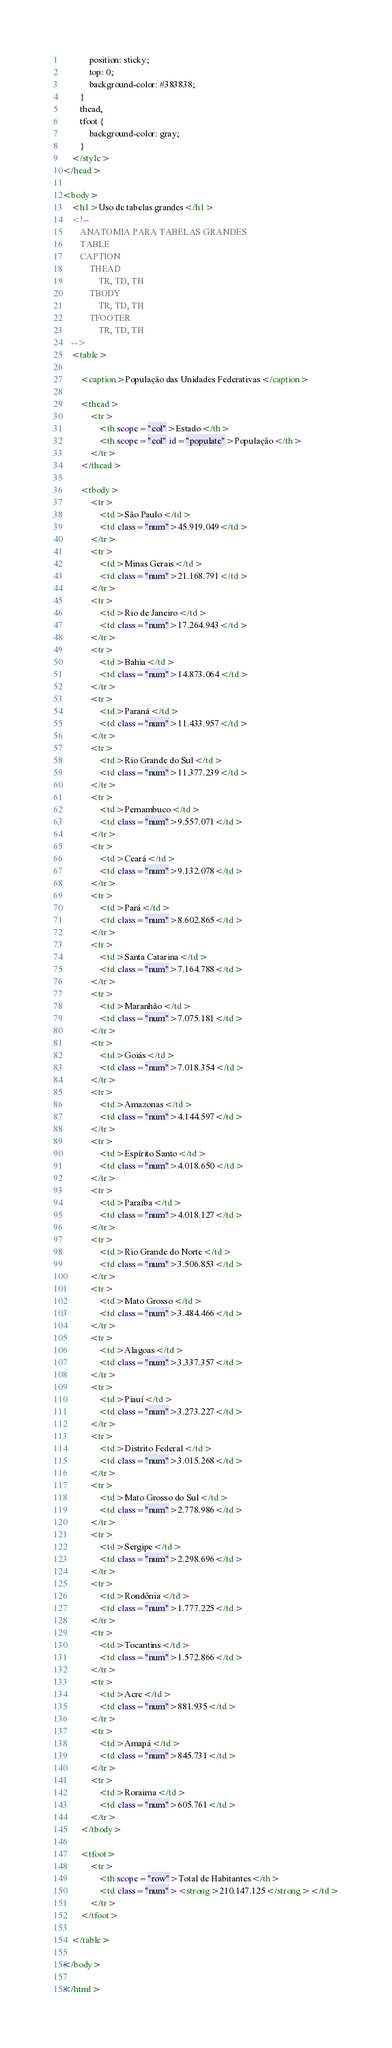Convert code to text. <code><loc_0><loc_0><loc_500><loc_500><_HTML_>            position: sticky;
            top: 0;
            background-color: #383838;
        }
        thead,
        tfoot {
            background-color: gray;
        }
    </style>
</head>

<body>
    <h1>Uso de tabelas grandes</h1>
    <!--
        ANATOMIA PARA TABELAS GRANDES
        TABLE
        CAPTION
            THEAD
                TR, TD, TH
            TBODY
                TR, TD, TH
            TFOOTER
                TR, TD, TH
    -->
    <table>

        <caption>População das Unidades Federativas</caption>

        <thead>
            <tr>
                <th scope="col">Estado</th>
                <th scope="col" id="populate">População</th>
            </tr>
        </thead>

        <tbody>
            <tr>
                <td>São Paulo</td>
                <td class="num">45.919.049</td>
            </tr>
            <tr>
                <td>Minas Gerais</td>
                <td class="num">21.168.791</td>
            </tr>
            <tr>
                <td>Rio de Janeiro</td>
                <td class="num">17.264.943</td>
            </tr>
            <tr>
                <td>Bahia</td>
                <td class="num">14.873.064</td>
            </tr>
            <tr>
                <td>Paraná</td>
                <td class="num">11.433.957</td>
            </tr>
            <tr>
                <td>Rio Grande do Sul</td>
                <td class="num">11.377.239</td>
            </tr>
            <tr>
                <td>Pernambuco</td>
                <td class="num">9.557.071</td>
            </tr>
            <tr>
                <td>Ceará</td>
                <td class="num">9.132.078</td>
            </tr>
            <tr>
                <td>Pará</td>
                <td class="num">8.602.865</td>
            </tr>
            <tr>
                <td>Santa Catarina</td>
                <td class="num">7.164.788</td>
            </tr>
            <tr>
                <td>Maranhão</td>
                <td class="num">7.075.181</td>
            </tr>
            <tr>
                <td>Goiás</td>
                <td class="num">7.018.354</td>
            </tr>
            <tr>
                <td>Amazonas</td>
                <td class="num">4.144.597</td>
            </tr>
            <tr>
                <td>Espírito Santo</td>
                <td class="num">4.018.650</td>
            </tr>
            <tr>
                <td>Paraíba</td>
                <td class="num">4.018.127</td>
            </tr>
            <tr>
                <td>Rio Grande do Norte</td>
                <td class="num">3.506.853</td>
            </tr>
            <tr>
                <td>Mato Grosso</td>
                <td class="num">3.484.466</td>
            </tr>
            <tr>
                <td>Alagoas</td>
                <td class="num">3.337.357</td>
            </tr>
            <tr>
                <td>Piauí</td>
                <td class="num">3.273.227</td>
            </tr>
            <tr>
                <td>Distrito Federal</td>
                <td class="num">3.015.268</td>
            </tr>
            <tr>
                <td>Mato Grosso do Sul</td>
                <td class="num">2.778.986</td>
            </tr>
            <tr>
                <td>Sergipe</td>
                <td class="num">2.298.696</td>
            </tr>
            <tr>
                <td>Rondônia</td>
                <td class="num">1.777.225</td>
            </tr>
            <tr>
                <td>Tocantins</td>
                <td class="num">1.572.866</td>
            </tr>
            <tr>
                <td>Acre</td>
                <td class="num">881.935</td>
            </tr>
            <tr>
                <td>Amapá</td>
                <td class="num">845.731</td>
            </tr>
            <tr>
                <td>Roraima</td>
                <td class="num">605.761</td>
            </tr>
        </tbody>

        <tfoot>
            <tr>
                <th scope="row">Total de Habitantes</th>
                <td class="num"><strong>210.147.125</strong></td>
            </tr>
        </tfoot>

    </table>

</body>

</html></code> 